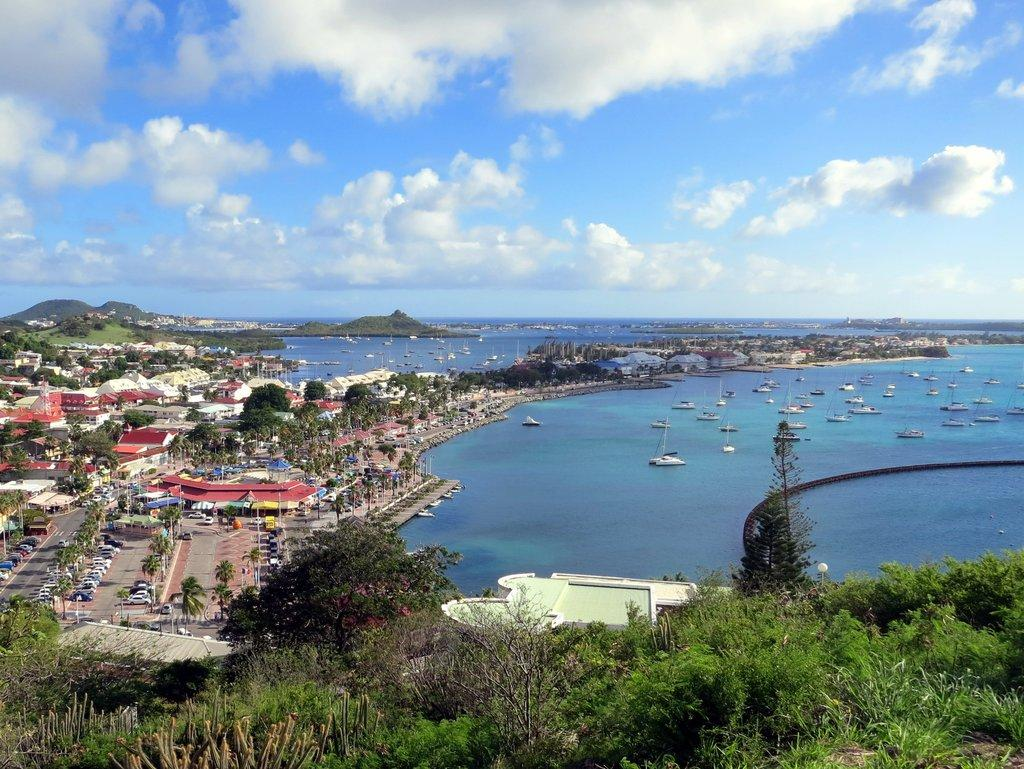What type of natural elements can be seen in the image? There are trees in the image. What type of man-made structures are present in the image? There are buildings in the image. What type of transportation is visible on the ground in the image? There are vehicles on the ground in the image. What type of transportation is visible on the water in the image? There are boats on the water in the image. What is visible in the background of the image? The sky is visible in the background of the image. What can be seen in the sky in the image? There are clouds in the sky. What type of jewel can be seen in the image? There is no jewel present in the image. How many planes are flying in the sky in the image? There are no planes visible in the image; only boats, vehicles, and clouds can be seen. 